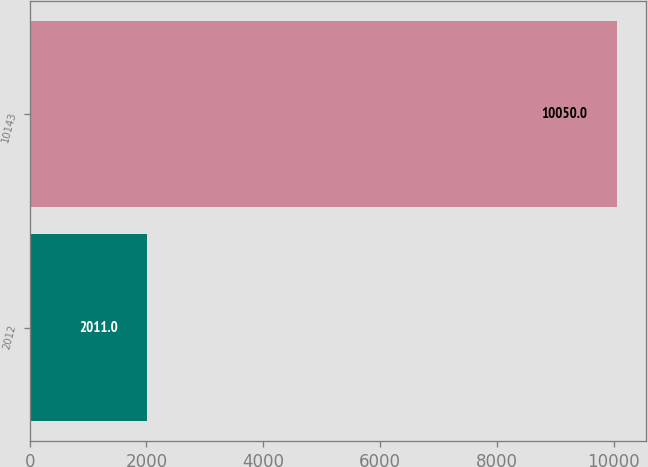Convert chart to OTSL. <chart><loc_0><loc_0><loc_500><loc_500><bar_chart><fcel>2012<fcel>10143<nl><fcel>2011<fcel>10050<nl></chart> 